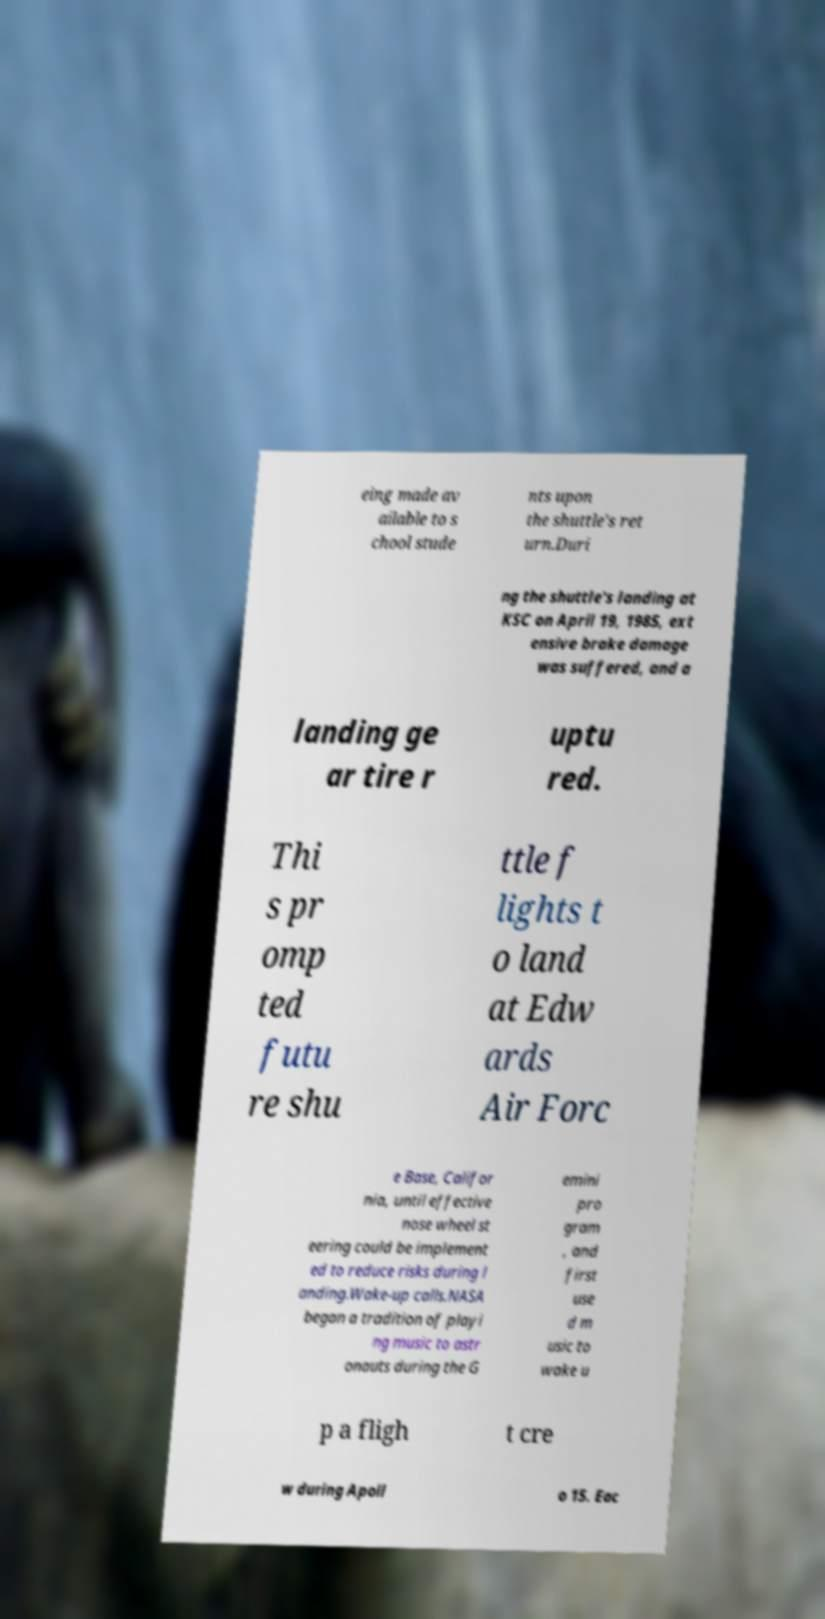Please identify and transcribe the text found in this image. eing made av ailable to s chool stude nts upon the shuttle's ret urn.Duri ng the shuttle's landing at KSC on April 19, 1985, ext ensive brake damage was suffered, and a landing ge ar tire r uptu red. Thi s pr omp ted futu re shu ttle f lights t o land at Edw ards Air Forc e Base, Califor nia, until effective nose wheel st eering could be implement ed to reduce risks during l anding.Wake-up calls.NASA began a tradition of playi ng music to astr onauts during the G emini pro gram , and first use d m usic to wake u p a fligh t cre w during Apoll o 15. Eac 